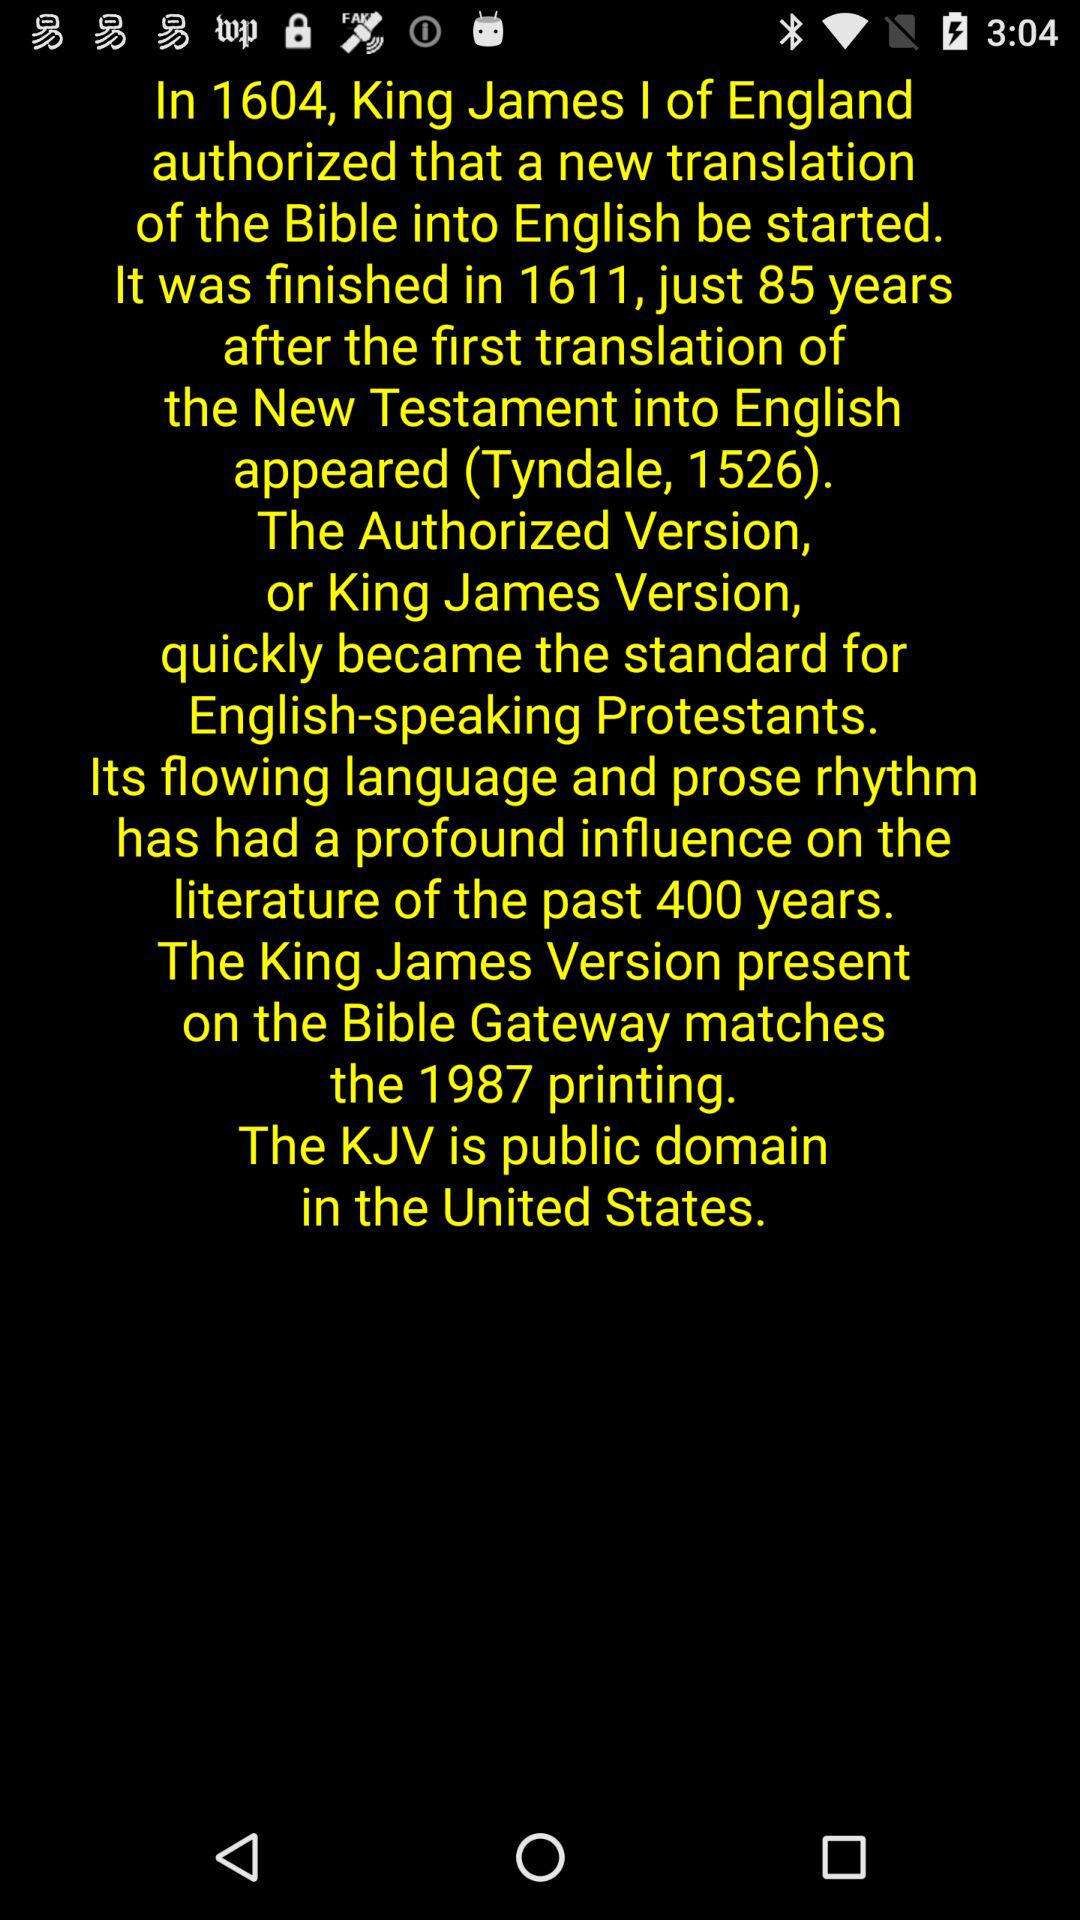What language was the Bible translated into? The Bible was translated into English. 